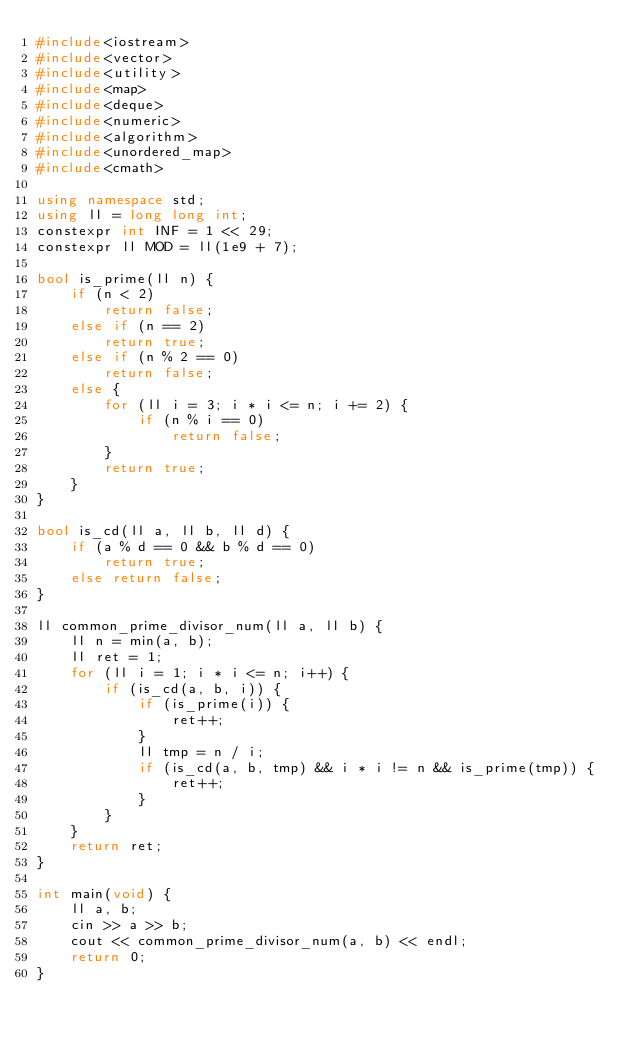<code> <loc_0><loc_0><loc_500><loc_500><_C++_>#include<iostream>
#include<vector>
#include<utility>
#include<map>
#include<deque>
#include<numeric>
#include<algorithm>
#include<unordered_map>
#include<cmath>

using namespace std;
using ll = long long int;
constexpr int INF = 1 << 29;
constexpr ll MOD = ll(1e9 + 7);

bool is_prime(ll n) {
	if (n < 2)
		return false;
	else if (n == 2)
		return true;
	else if (n % 2 == 0)
		return false;
	else {
		for (ll i = 3; i * i <= n; i += 2) {
			if (n % i == 0)
				return false;
		}
		return true;
	}
}

bool is_cd(ll a, ll b, ll d) {
	if (a % d == 0 && b % d == 0)
		return true;
	else return false;
}

ll common_prime_divisor_num(ll a, ll b) {
	ll n = min(a, b);
	ll ret = 1;
	for (ll i = 1; i * i <= n; i++) {
		if (is_cd(a, b, i)) {
			if (is_prime(i)) {
				ret++;
			}
			ll tmp = n / i;
			if (is_cd(a, b, tmp) && i * i != n && is_prime(tmp)) {
				ret++;
			}
		}
	}
	return ret;
}

int main(void) {
	ll a, b;
	cin >> a >> b;
	cout << common_prime_divisor_num(a, b) << endl;
	return 0;
}</code> 